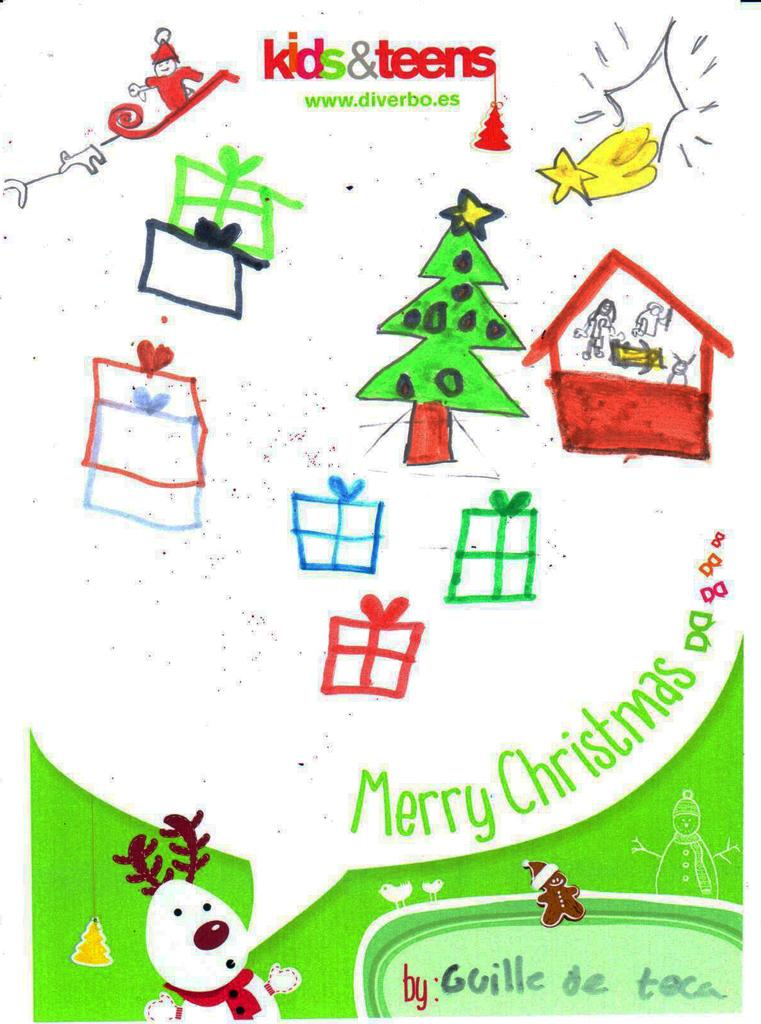What type of artwork is featured in the image? The image contains cartoon pictures and sketch paintings. Can you describe the text written on the image? There is text written on the top of the image and on the bottom right side of the image. What is the purpose of the text in the image? The purpose of the text is not specified in the facts provided. What type of show is taking place downtown in the image? There is no show or downtown location depicted in the image; it features cartoon pictures, sketch paintings, and text. 